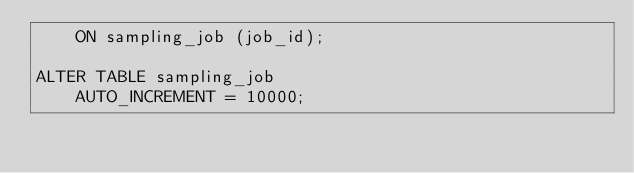Convert code to text. <code><loc_0><loc_0><loc_500><loc_500><_SQL_>    ON sampling_job (job_id);

ALTER TABLE sampling_job
    AUTO_INCREMENT = 10000;

</code> 